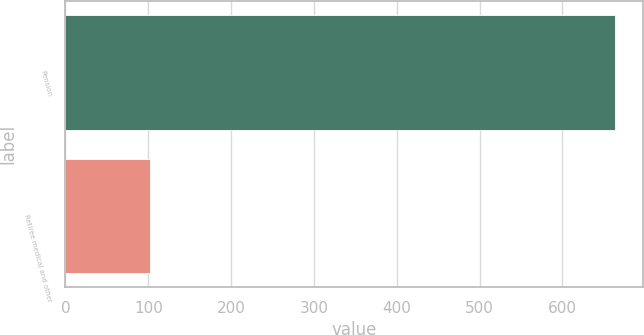Convert chart. <chart><loc_0><loc_0><loc_500><loc_500><bar_chart><fcel>Pension<fcel>Retiree medical and other<nl><fcel>664<fcel>102<nl></chart> 